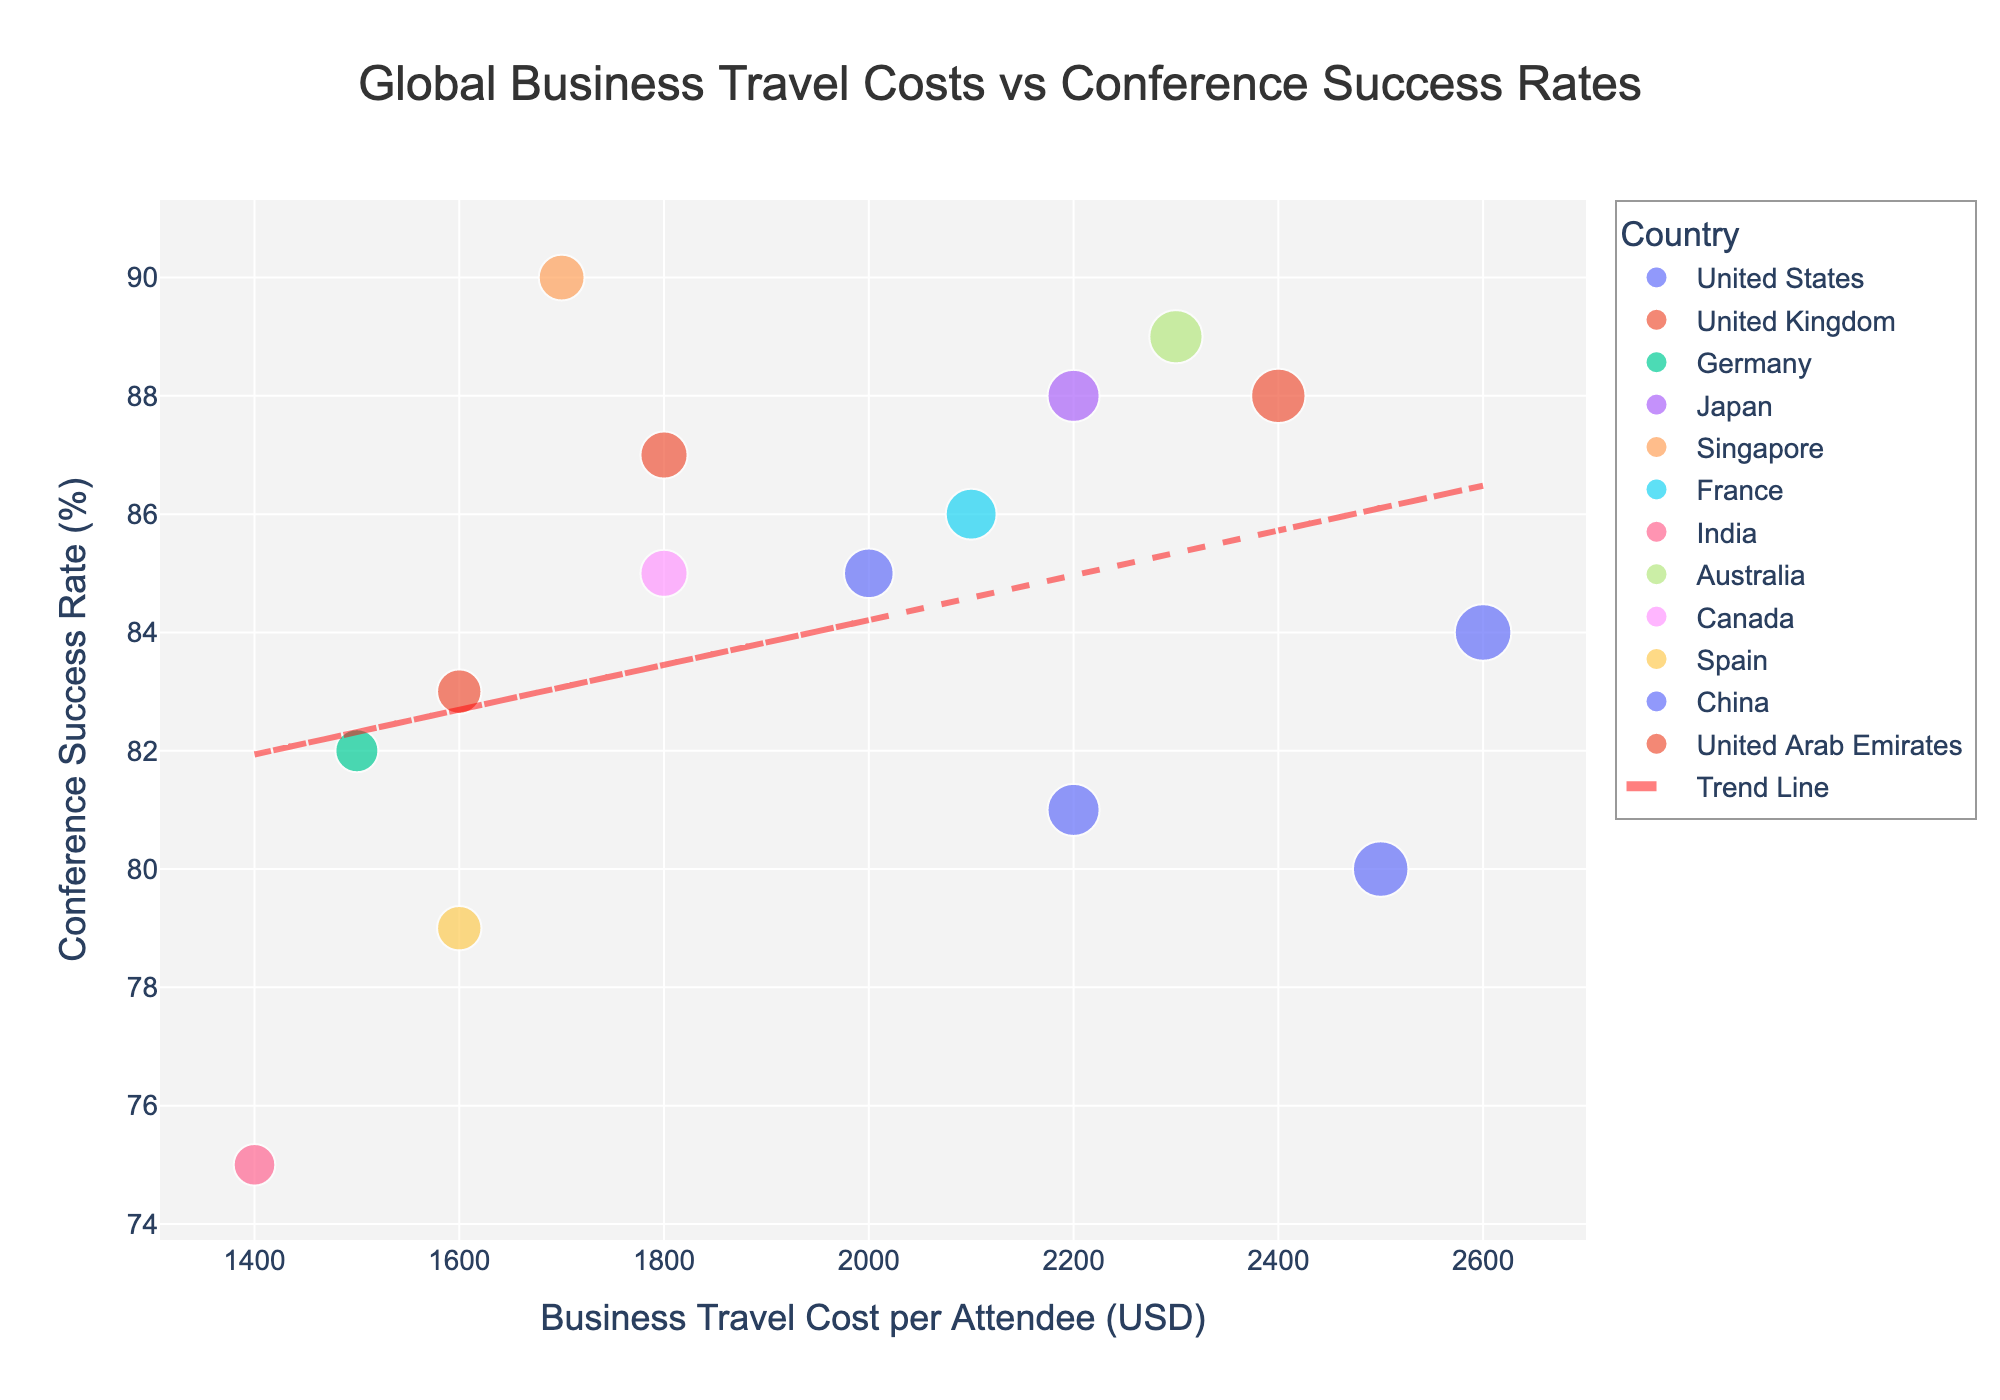what is the title of the scatter plot? The title is located at the center top of the plot, providing an overview of what the plot represents. From the plot, the title reads 'Global Business Travel Costs vs Conference Success Rates'.
Answer: Global Business Travel Costs vs Conference Success Rates What is the range of values on the x-axis? The x-axis represents 'Business Travel Cost per Attendee (USD)', displaying the range of values for this metric. From the plot, the x-axis starts at 1000 USD and ends at 2700 USD.
Answer: 1000 to 2700 USD Which city had the highest conference success rate? Observing the scatter plot, each data point's tooltip contains information about the city and its success rate. The highest success rate is 90%, which is associated with Singapore.
Answer: Singapore How many data points fall within the range of 1500 to 2000 USD for business travel costs? Counting the number of data points between 1500 and 2000 USD on the x-axis, we find New York, London, Berlin, Edinburgh, Paris, Toronto, and Madrid. There are 7 data points in this range.
Answer: 7 data points Is there a positive or negative trend observed in conference success rates as business travel costs increase? The trend line added to the scatter plot shows the general direction of the relationship between the variables. As the business travel costs increase, the trend line moves in a slightly upward direction, indicating a positive trend.
Answer: Positive Which country had the most data points represented in the years shown? To determine the country with the most data points, we look at the scatter plot with each country's color coding and point count. The United States has the most data points with 3 cities (New York, San Francisco, and Chicago).
Answer: United States What's the average conference success rate of cities in 2020? From the plot, the cities in 2020 are San Francisco, Edinburgh, Paris, Bangalore, and Sydney, with success rates of 80%, 83%, 86%, 75%, and 89%, respectively. The average is calculated as (80+83+86+75+89)/5 = 82.6%.
Answer: 82.6% Which city had the highest business travel cost per attendee in 2021? Checking the data points for the year 2021, the cities are Chicago, Toronto, Madrid, Shanghai, and Dubai. The highest business travel cost is 2600 USD in Chicago.
Answer: Chicago What's the difference in conference success rates between the city with the highest and the lowest cost in 2020? In 2020, the highest cost is San Francisco (2500 USD) with an 80% success rate, and the lowest is Bangalore (1400 USD) with a 75% success rate. The difference is 80% - 75% = 5%.
Answer: 5% Do higher business travel costs always correlate with higher conference success rates? Observing the scatter plot and the trend line, while there is a slight positive trend, not all higher costs correlate with higher success rates. For example, San Francisco has a high cost but a lower success rate (80%), whereas Sydney has both high cost and high success rate (89%).
Answer: Not always 